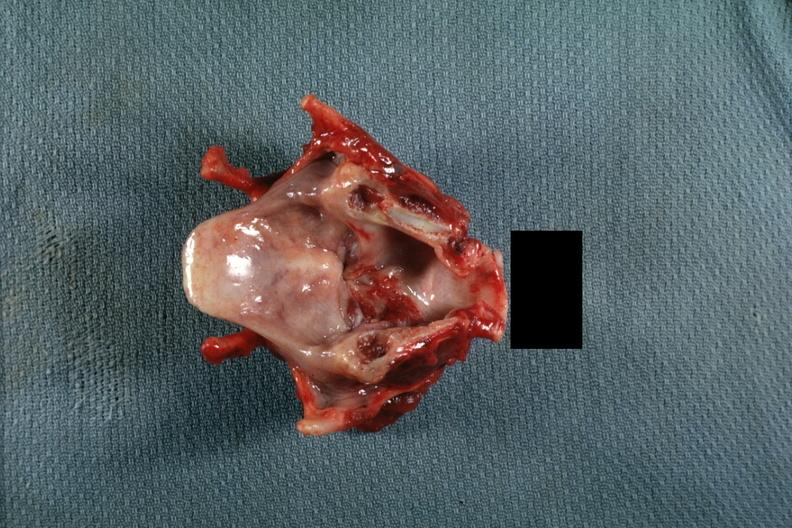what does this image show?
Answer the question using a single word or phrase. Excellent granular lesion on true cord extending inferior 